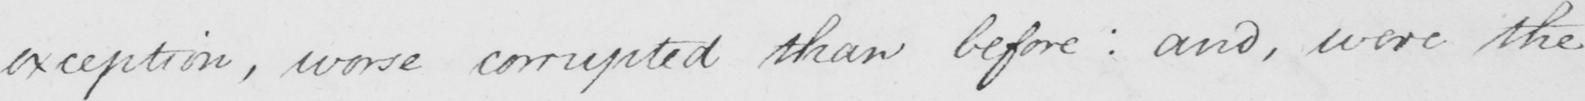Please transcribe the handwritten text in this image. exception , worse corrupted than before :  and , where the 